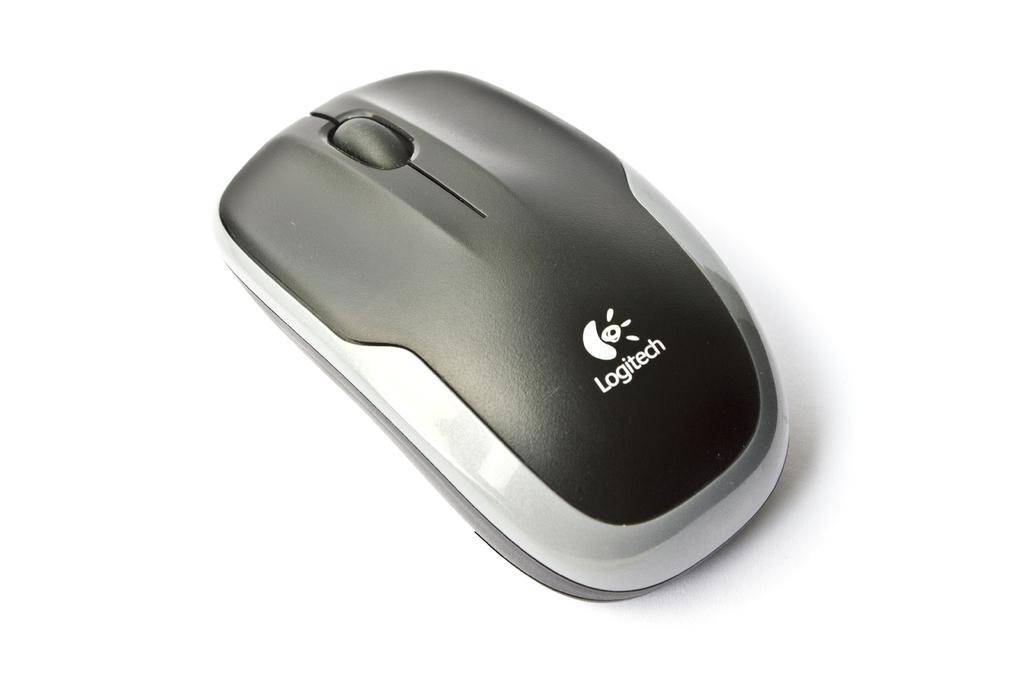Please provide a concise description of this image. In this image we can see a mouse. 